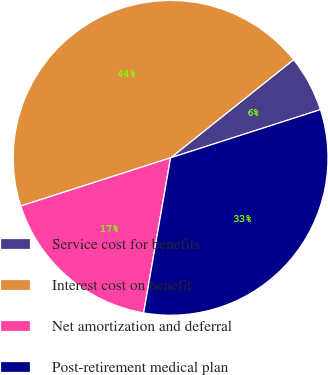Convert chart to OTSL. <chart><loc_0><loc_0><loc_500><loc_500><pie_chart><fcel>Service cost for benefits<fcel>Interest cost on benefit<fcel>Net amortization and deferral<fcel>Post-retirement medical plan<nl><fcel>5.77%<fcel>44.23%<fcel>17.31%<fcel>32.69%<nl></chart> 